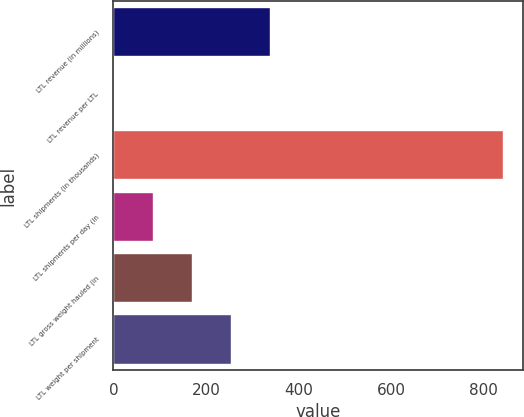Convert chart. <chart><loc_0><loc_0><loc_500><loc_500><bar_chart><fcel>LTL revenue (in millions)<fcel>LTL revenue per LTL<fcel>LTL shipments (in thousands)<fcel>LTL shipments per day (in<fcel>LTL gross weight hauled (in<fcel>LTL weight per shipment<nl><fcel>338.08<fcel>1.48<fcel>843<fcel>85.63<fcel>169.78<fcel>253.93<nl></chart> 